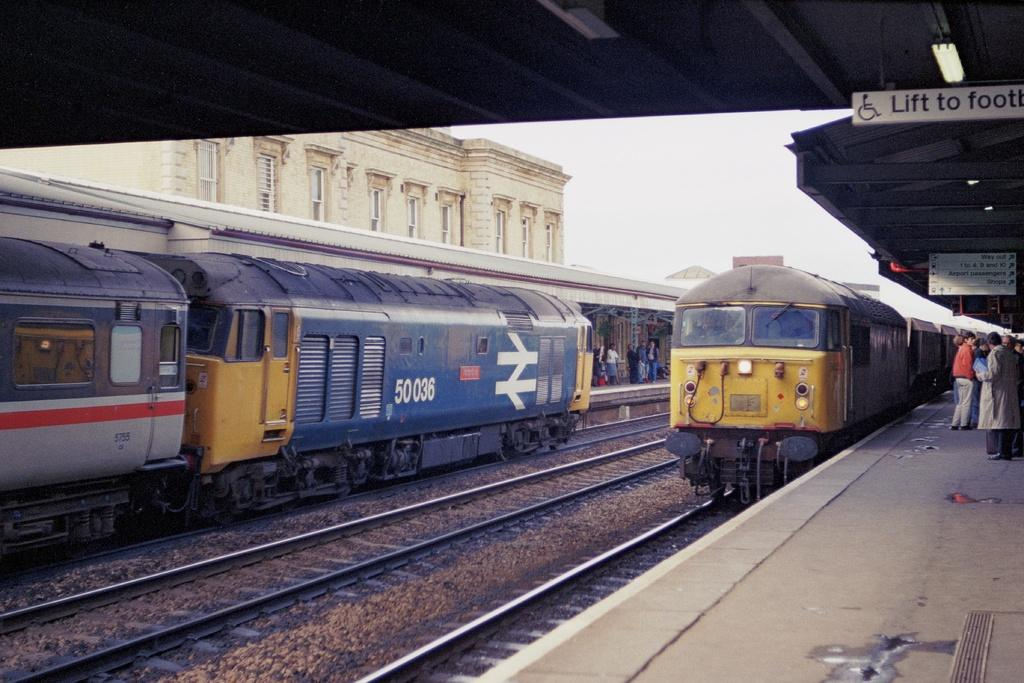<image>
Provide a brief description of the given image. A train that says 50036 on the side of it. 